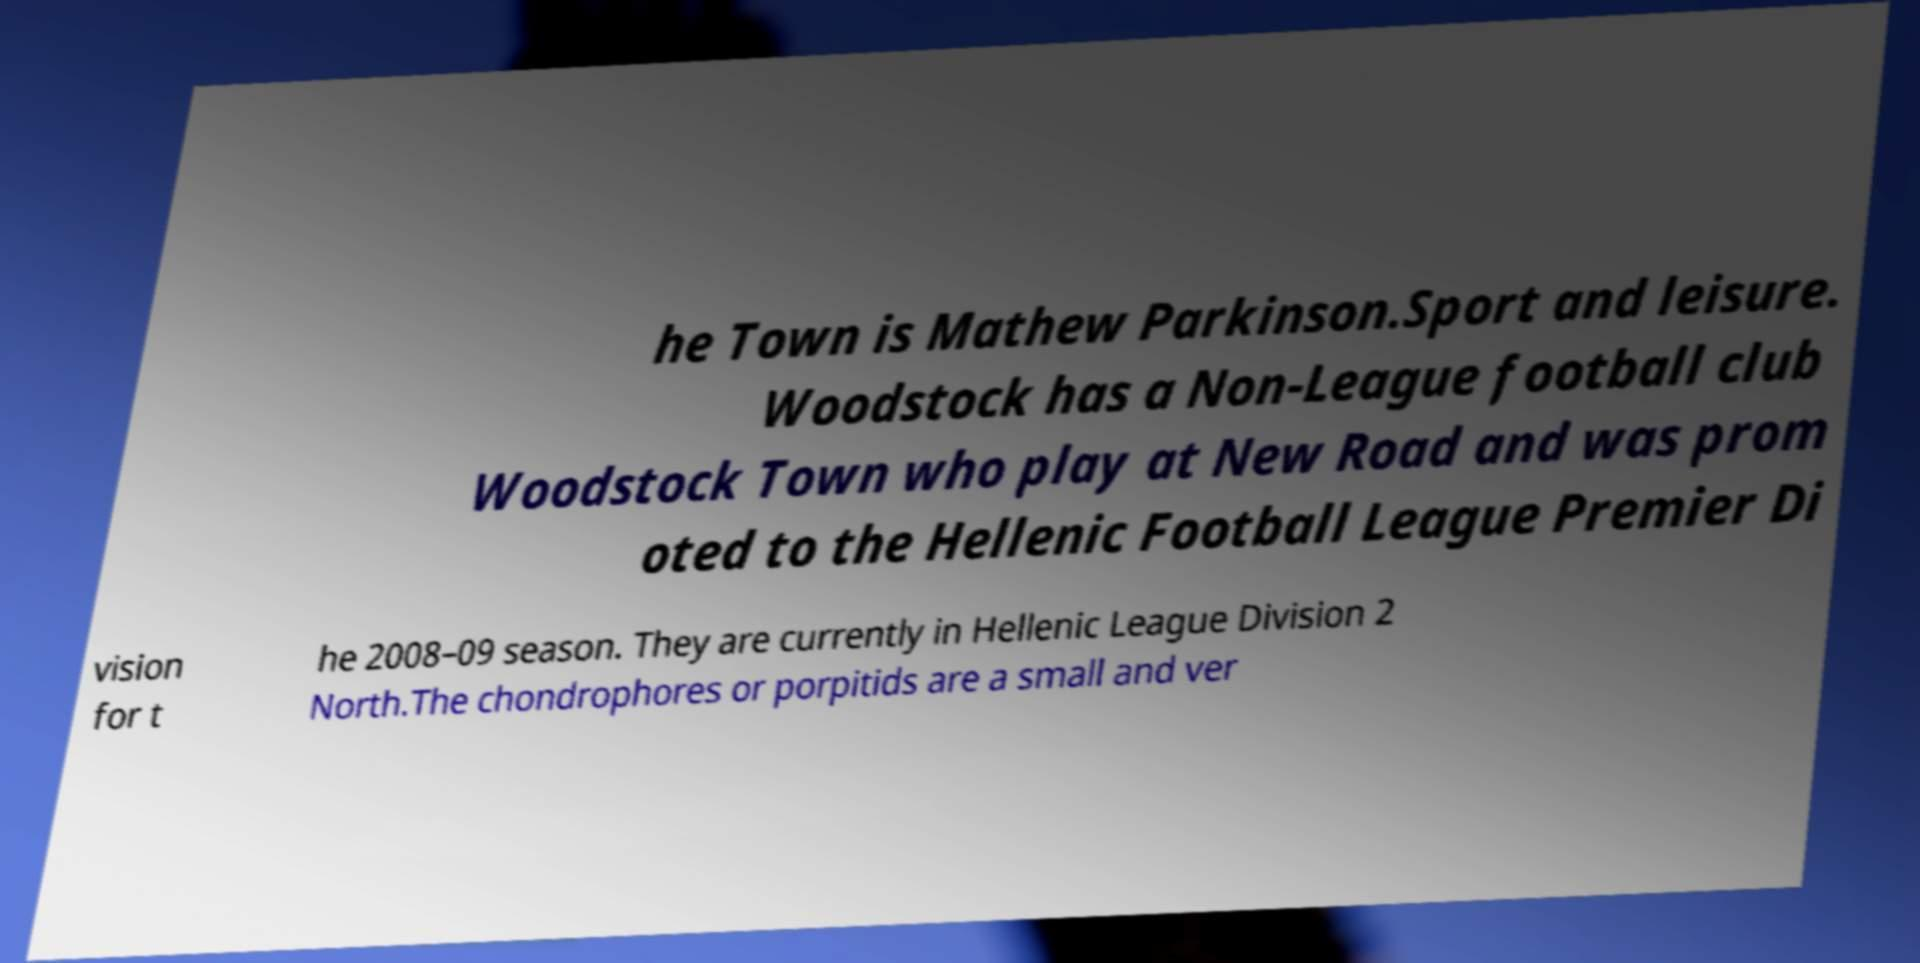Please identify and transcribe the text found in this image. he Town is Mathew Parkinson.Sport and leisure. Woodstock has a Non-League football club Woodstock Town who play at New Road and was prom oted to the Hellenic Football League Premier Di vision for t he 2008–09 season. They are currently in Hellenic League Division 2 North.The chondrophores or porpitids are a small and ver 